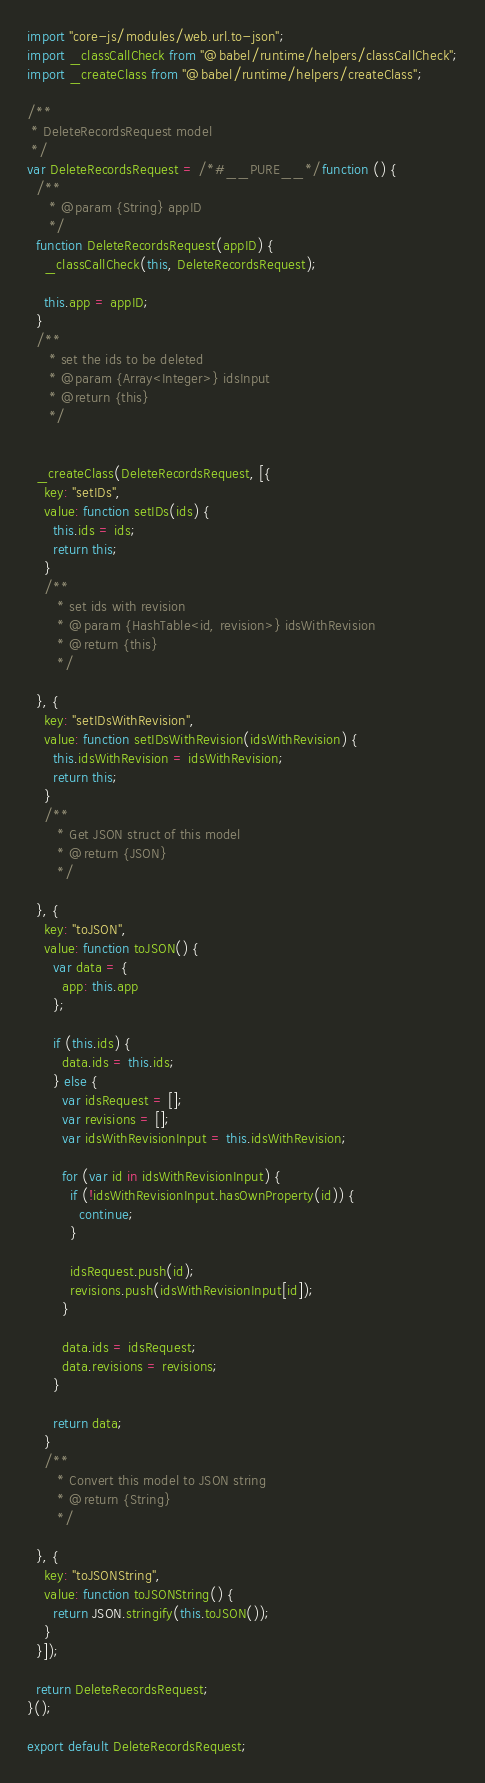<code> <loc_0><loc_0><loc_500><loc_500><_JavaScript_>import "core-js/modules/web.url.to-json";
import _classCallCheck from "@babel/runtime/helpers/classCallCheck";
import _createClass from "@babel/runtime/helpers/createClass";

/**
 * DeleteRecordsRequest model
 */
var DeleteRecordsRequest = /*#__PURE__*/function () {
  /**
     * @param {String} appID
     */
  function DeleteRecordsRequest(appID) {
    _classCallCheck(this, DeleteRecordsRequest);

    this.app = appID;
  }
  /**
     * set the ids to be deleted
     * @param {Array<Integer>} idsInput
     * @return {this}
     */


  _createClass(DeleteRecordsRequest, [{
    key: "setIDs",
    value: function setIDs(ids) {
      this.ids = ids;
      return this;
    }
    /**
       * set ids with revision
       * @param {HashTable<id, revision>} idsWithRevision
       * @return {this}
       */

  }, {
    key: "setIDsWithRevision",
    value: function setIDsWithRevision(idsWithRevision) {
      this.idsWithRevision = idsWithRevision;
      return this;
    }
    /**
       * Get JSON struct of this model
       * @return {JSON}
       */

  }, {
    key: "toJSON",
    value: function toJSON() {
      var data = {
        app: this.app
      };

      if (this.ids) {
        data.ids = this.ids;
      } else {
        var idsRequest = [];
        var revisions = [];
        var idsWithRevisionInput = this.idsWithRevision;

        for (var id in idsWithRevisionInput) {
          if (!idsWithRevisionInput.hasOwnProperty(id)) {
            continue;
          }

          idsRequest.push(id);
          revisions.push(idsWithRevisionInput[id]);
        }

        data.ids = idsRequest;
        data.revisions = revisions;
      }

      return data;
    }
    /**
       * Convert this model to JSON string
       * @return {String}
       */

  }, {
    key: "toJSONString",
    value: function toJSONString() {
      return JSON.stringify(this.toJSON());
    }
  }]);

  return DeleteRecordsRequest;
}();

export default DeleteRecordsRequest;</code> 